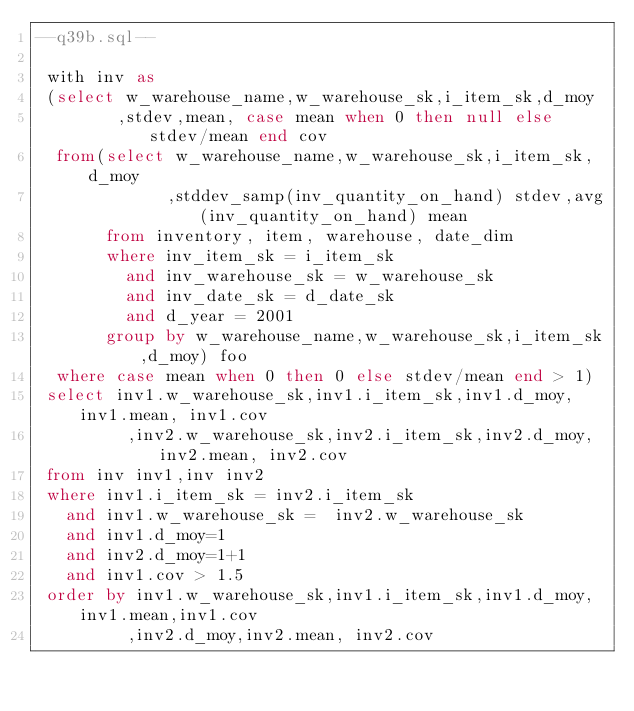<code> <loc_0><loc_0><loc_500><loc_500><_SQL_>--q39b.sql--

 with inv as
 (select w_warehouse_name,w_warehouse_sk,i_item_sk,d_moy
        ,stdev,mean, case mean when 0 then null else stdev/mean end cov
  from(select w_warehouse_name,w_warehouse_sk,i_item_sk,d_moy
             ,stddev_samp(inv_quantity_on_hand) stdev,avg(inv_quantity_on_hand) mean
       from inventory, item, warehouse, date_dim
       where inv_item_sk = i_item_sk
         and inv_warehouse_sk = w_warehouse_sk
         and inv_date_sk = d_date_sk
         and d_year = 2001
       group by w_warehouse_name,w_warehouse_sk,i_item_sk,d_moy) foo
  where case mean when 0 then 0 else stdev/mean end > 1)
 select inv1.w_warehouse_sk,inv1.i_item_sk,inv1.d_moy,inv1.mean, inv1.cov
         ,inv2.w_warehouse_sk,inv2.i_item_sk,inv2.d_moy,inv2.mean, inv2.cov
 from inv inv1,inv inv2
 where inv1.i_item_sk = inv2.i_item_sk
   and inv1.w_warehouse_sk =  inv2.w_warehouse_sk
   and inv1.d_moy=1
   and inv2.d_moy=1+1
   and inv1.cov > 1.5
 order by inv1.w_warehouse_sk,inv1.i_item_sk,inv1.d_moy,inv1.mean,inv1.cov
         ,inv2.d_moy,inv2.mean, inv2.cov
            
</code> 